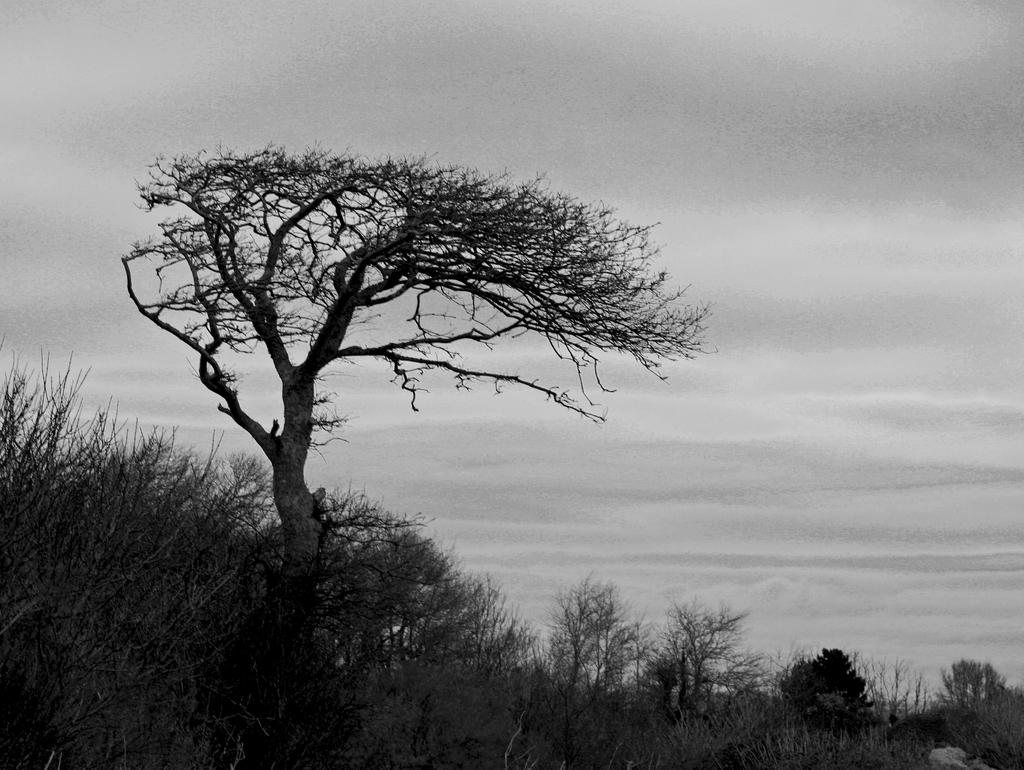What is the color scheme of the image? The image is black and white. What type of vegetation can be seen in the image? There are plants and trees in the image. What can be seen in the background of the image? The sky is visible in the background of the image. What type of door can be seen in the image? There is no door present in the image. Who is the manager of the plants in the image? The image does not depict a manager or any human presence, so it is not possible to determine who might be managing the plants. 